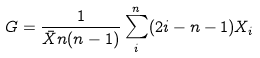Convert formula to latex. <formula><loc_0><loc_0><loc_500><loc_500>G = \frac { 1 } { \bar { X } n ( n - 1 ) } \sum _ { i } ^ { n } ( 2 i - n - 1 ) X _ { i }</formula> 